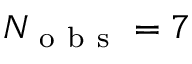<formula> <loc_0><loc_0><loc_500><loc_500>N _ { o b s } = 7</formula> 